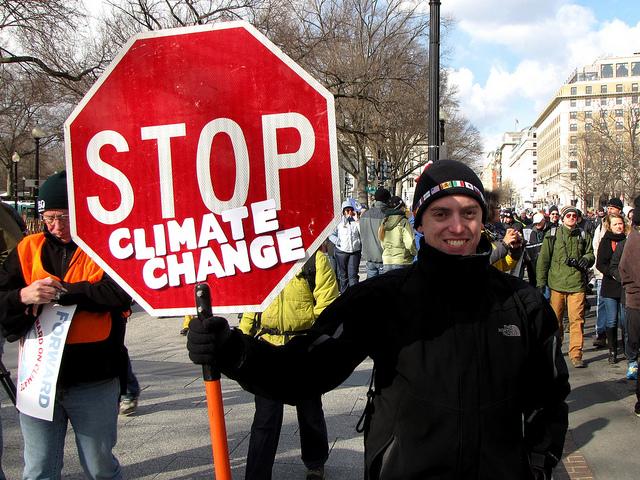What is this rally for?
Short answer required. Climate change. Who believes the climate is changing?
Write a very short answer. Man. Is the regular stop sign found in the street?
Keep it brief. No. 